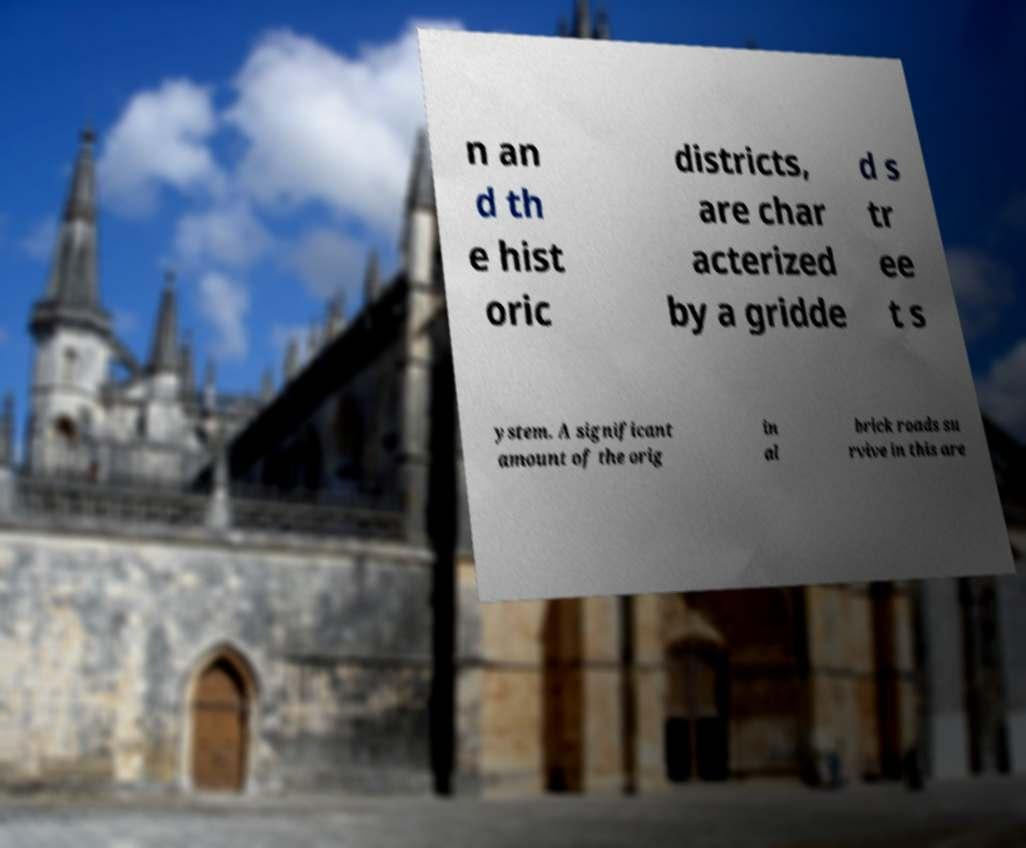Can you accurately transcribe the text from the provided image for me? n an d th e hist oric districts, are char acterized by a gridde d s tr ee t s ystem. A significant amount of the orig in al brick roads su rvive in this are 